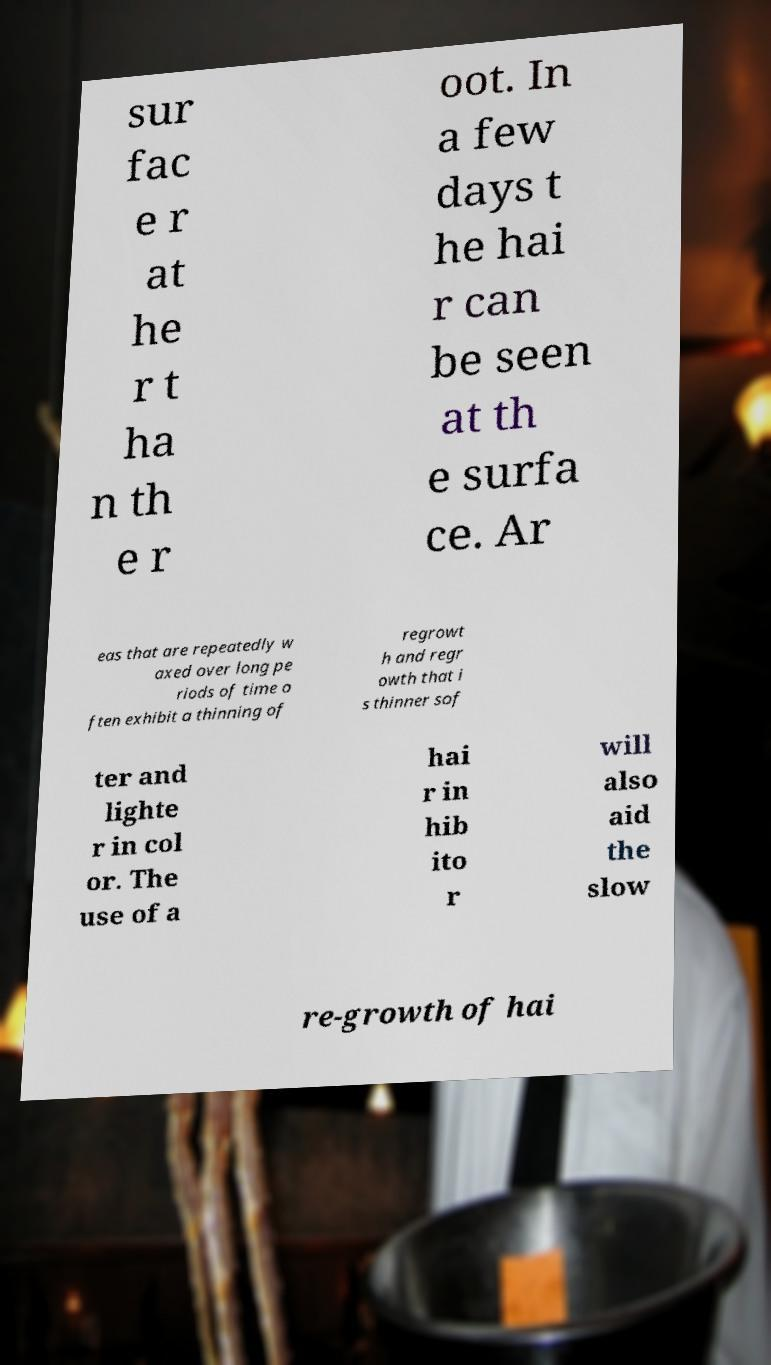There's text embedded in this image that I need extracted. Can you transcribe it verbatim? sur fac e r at he r t ha n th e r oot. In a few days t he hai r can be seen at th e surfa ce. Ar eas that are repeatedly w axed over long pe riods of time o ften exhibit a thinning of regrowt h and regr owth that i s thinner sof ter and lighte r in col or. The use of a hai r in hib ito r will also aid the slow re-growth of hai 